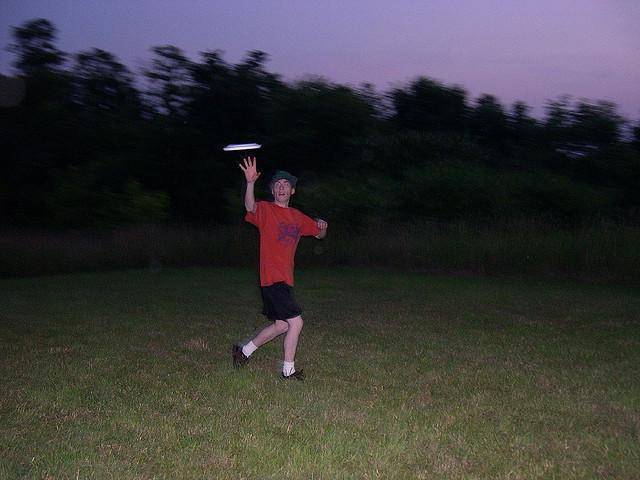What is the boy trying to catch?
Concise answer only. Frisbee. What color is the disk?
Concise answer only. White. How many girls are in this picture?
Answer briefly. 0. How are the skies?
Answer briefly. Dark. What are the guys doing?
Give a very brief answer. Frisbee. Is it dark out?
Keep it brief. Yes. Which border is ahead?
Write a very short answer. None. Was this picture taken during the day?
Short answer required. No. Is the grass thick and plush looking?
Keep it brief. Yes. Is this person wearing a hat?
Quick response, please. Yes. Is this a man or woman?
Give a very brief answer. Man. 